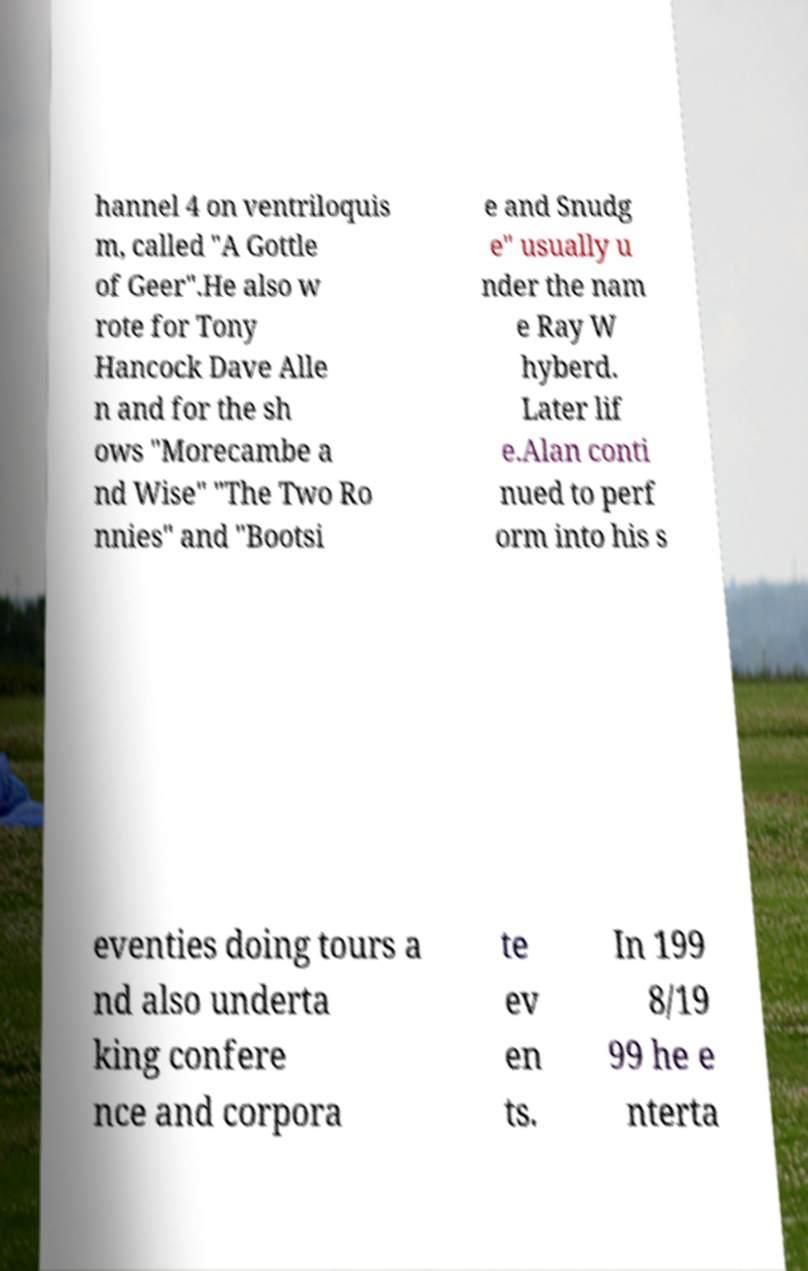Could you extract and type out the text from this image? hannel 4 on ventriloquis m, called "A Gottle of Geer".He also w rote for Tony Hancock Dave Alle n and for the sh ows "Morecambe a nd Wise" "The Two Ro nnies" and "Bootsi e and Snudg e" usually u nder the nam e Ray W hyberd. Later lif e.Alan conti nued to perf orm into his s eventies doing tours a nd also underta king confere nce and corpora te ev en ts. In 199 8/19 99 he e nterta 